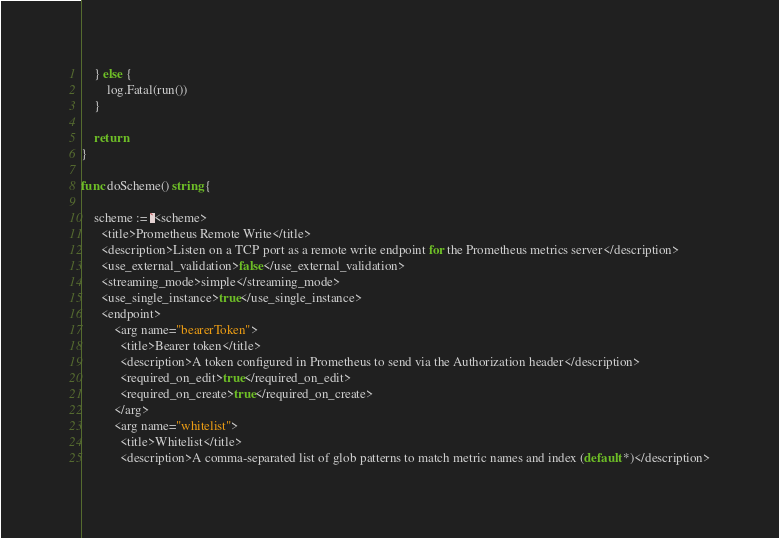Convert code to text. <code><loc_0><loc_0><loc_500><loc_500><_Go_>	} else {
		log.Fatal(run())
	}

	return
}

func doScheme() string {

	scheme := `<scheme>
      <title>Prometheus Remote Write</title>
      <description>Listen on a TCP port as a remote write endpoint for the Prometheus metrics server</description>
      <use_external_validation>false</use_external_validation>
      <streaming_mode>simple</streaming_mode>
      <use_single_instance>true</use_single_instance>
      <endpoint>
          <arg name="bearerToken">
            <title>Bearer token</title>
            <description>A token configured in Prometheus to send via the Authorization header</description>
            <required_on_edit>true</required_on_edit>
            <required_on_create>true</required_on_create>
          </arg>
          <arg name="whitelist">
            <title>Whitelist</title>
            <description>A comma-separated list of glob patterns to match metric names and index (default *)</description></code> 